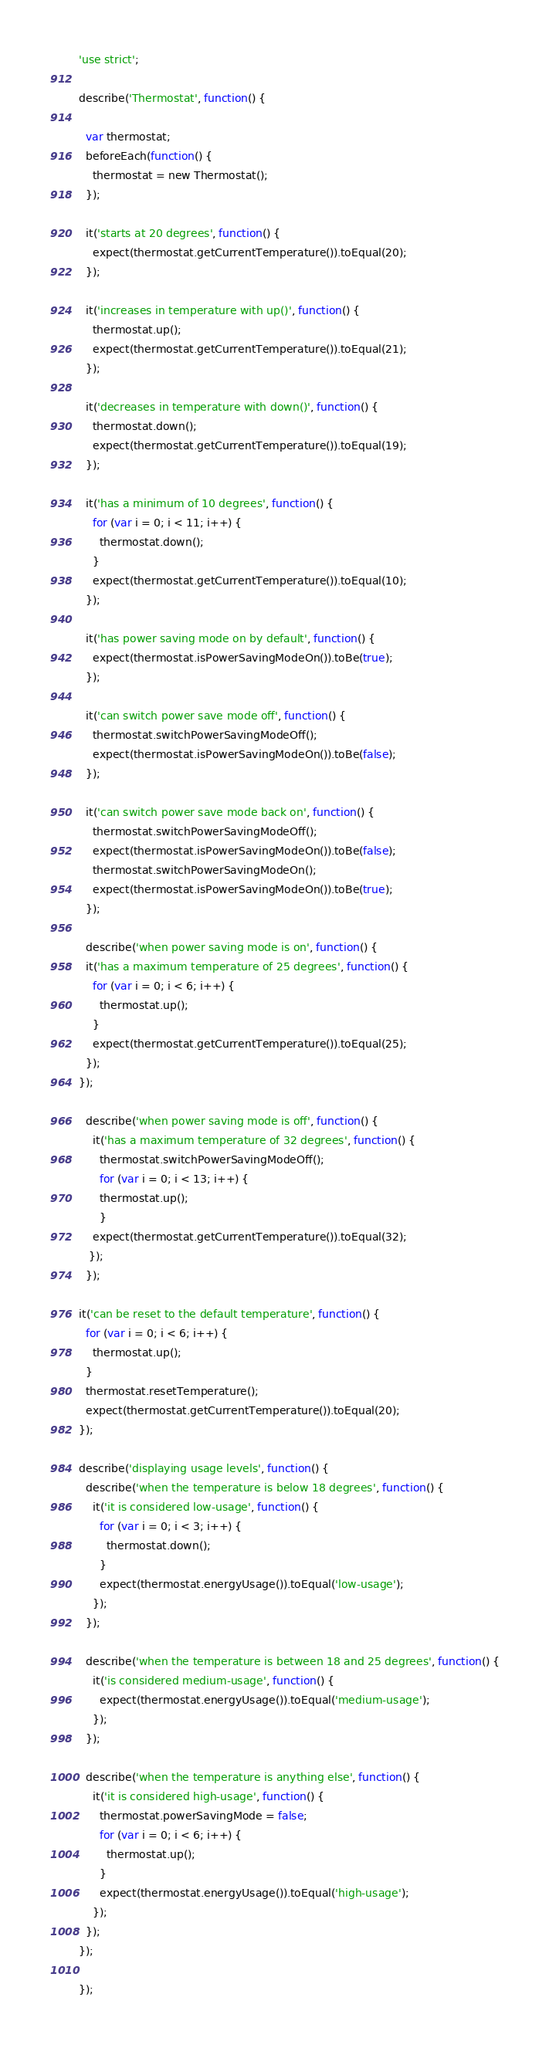<code> <loc_0><loc_0><loc_500><loc_500><_JavaScript_>'use strict';

describe('Thermostat', function() {

  var thermostat;
  beforeEach(function() {
    thermostat = new Thermostat();
  });

  it('starts at 20 degrees', function() {
    expect(thermostat.getCurrentTemperature()).toEqual(20);
  });

  it('increases in temperature with up()', function() {
    thermostat.up();
    expect(thermostat.getCurrentTemperature()).toEqual(21);
  });

  it('decreases in temperature with down()', function() {
    thermostat.down();
    expect(thermostat.getCurrentTemperature()).toEqual(19);
  });

  it('has a minimum of 10 degrees', function() {
    for (var i = 0; i < 11; i++) {
      thermostat.down();
    }
    expect(thermostat.getCurrentTemperature()).toEqual(10);
  });

  it('has power saving mode on by default', function() {
    expect(thermostat.isPowerSavingModeOn()).toBe(true);
  });

  it('can switch power save mode off', function() {
    thermostat.switchPowerSavingModeOff();
    expect(thermostat.isPowerSavingModeOn()).toBe(false);
  });

  it('can switch power save mode back on', function() {
    thermostat.switchPowerSavingModeOff();
    expect(thermostat.isPowerSavingModeOn()).toBe(false);
    thermostat.switchPowerSavingModeOn();
    expect(thermostat.isPowerSavingModeOn()).toBe(true);
  });

  describe('when power saving mode is on', function() {
  it('has a maximum temperature of 25 degrees', function() {
    for (var i = 0; i < 6; i++) {
      thermostat.up();
    }
    expect(thermostat.getCurrentTemperature()).toEqual(25);
  });
});

  describe('when power saving mode is off', function() {
    it('has a maximum temperature of 32 degrees', function() {
      thermostat.switchPowerSavingModeOff();
      for (var i = 0; i < 13; i++) {
      thermostat.up();
      }
    expect(thermostat.getCurrentTemperature()).toEqual(32);
   });
  });

it('can be reset to the default temperature', function() {
  for (var i = 0; i < 6; i++) {
    thermostat.up();
  }
  thermostat.resetTemperature();
  expect(thermostat.getCurrentTemperature()).toEqual(20);
});

describe('displaying usage levels', function() {
  describe('when the temperature is below 18 degrees', function() {
    it('it is considered low-usage', function() {
      for (var i = 0; i < 3; i++) {
        thermostat.down();
      }
      expect(thermostat.energyUsage()).toEqual('low-usage');
    });
  });

  describe('when the temperature is between 18 and 25 degrees', function() {
    it('is considered medium-usage', function() {
      expect(thermostat.energyUsage()).toEqual('medium-usage');
    });
  });

  describe('when the temperature is anything else', function() {
    it('it is considered high-usage', function() {
      thermostat.powerSavingMode = false;
      for (var i = 0; i < 6; i++) {
        thermostat.up();
      }
      expect(thermostat.energyUsage()).toEqual('high-usage');
    });
  });
});

});
</code> 